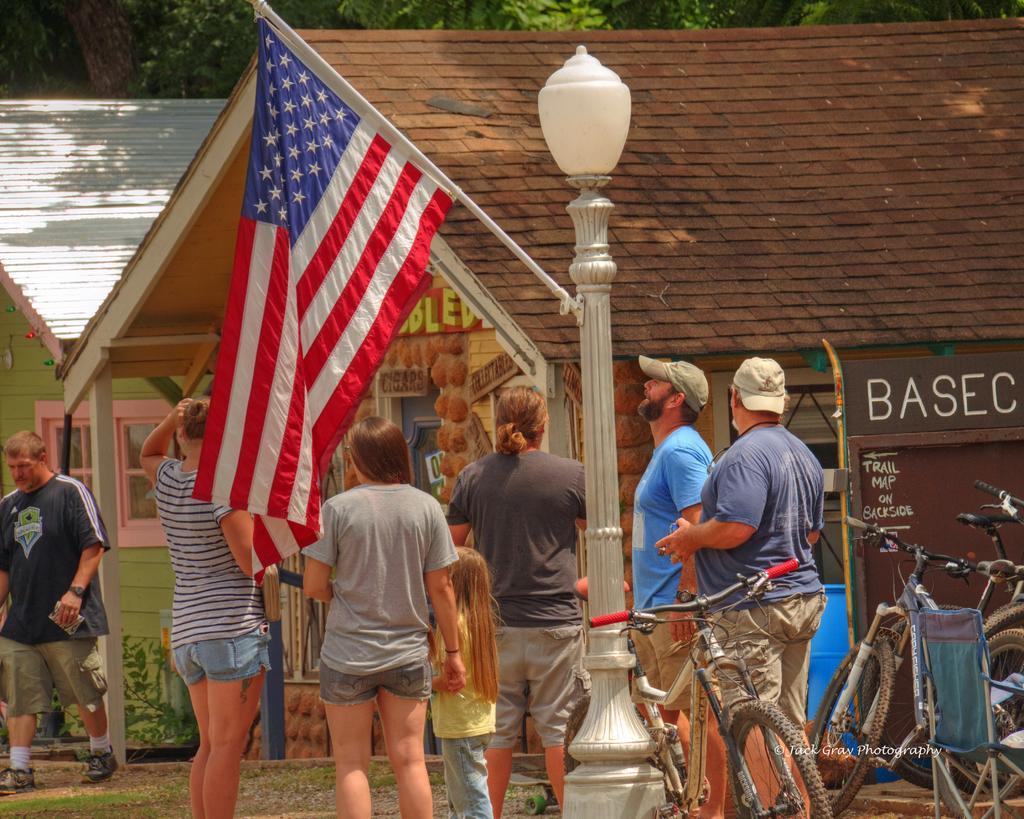Can you describe this image briefly? In this image we can see persons standing on the ground, building, trees, bicycles, plants, street pole to which a flag is attached and a street light. 